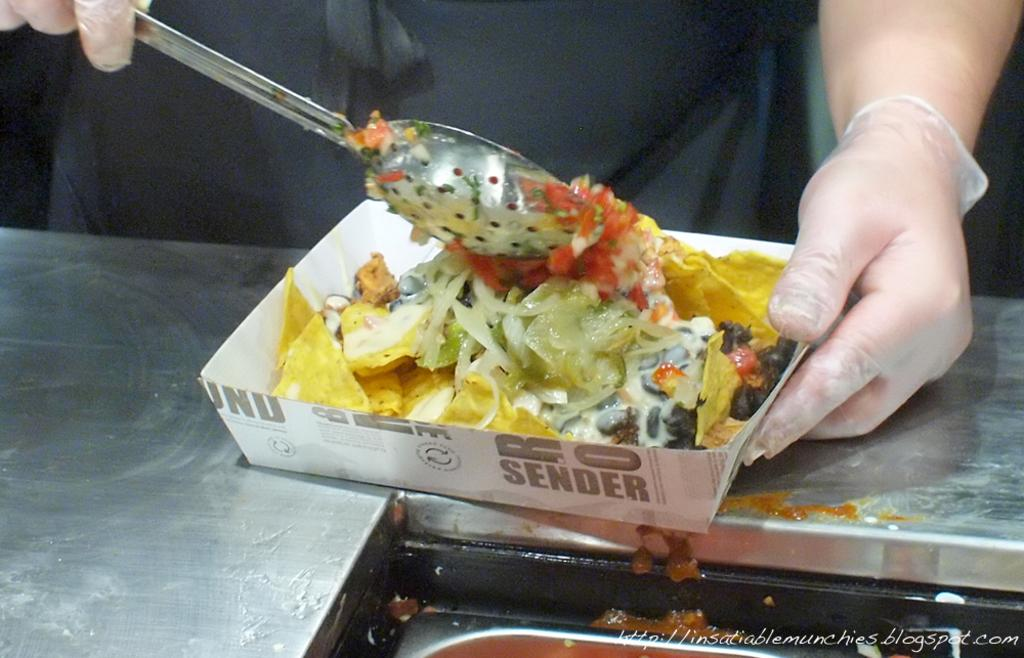What type of container is holding the food in the image? There is food in a box in the image. Where is the food placed? The food is placed on a table. Can you describe the person in the background of the image? The person in the background is holding a spatula. What month is depicted in the image? There is no specific month depicted in the image; it only shows food in a box, a table, and a person holding a spatula. 